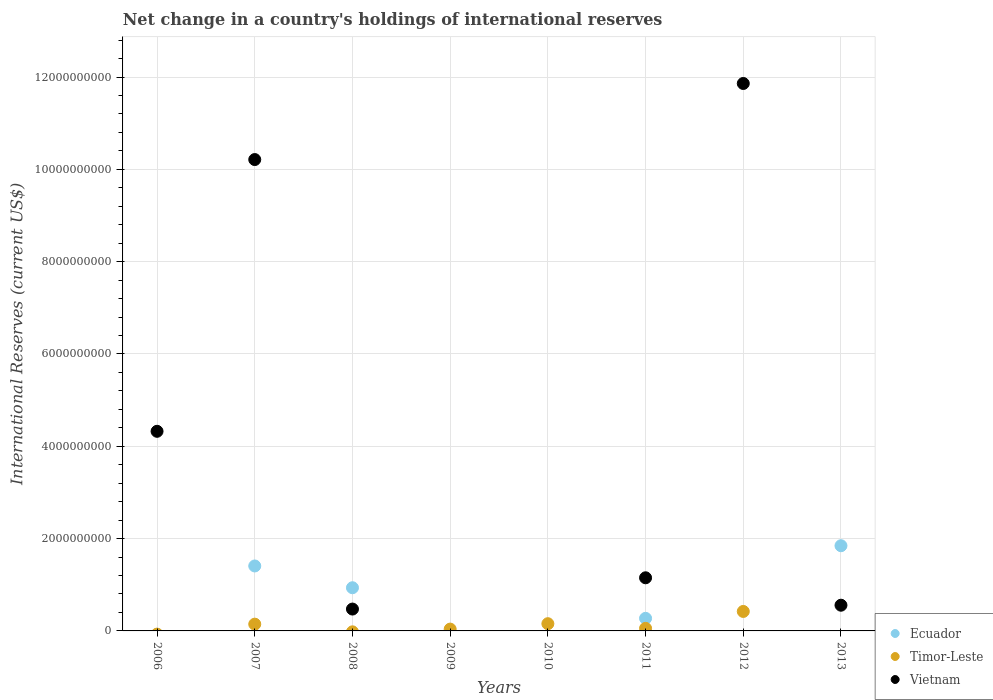What is the international reserves in Vietnam in 2008?
Give a very brief answer. 4.74e+08. Across all years, what is the maximum international reserves in Ecuador?
Provide a succinct answer. 1.85e+09. Across all years, what is the minimum international reserves in Ecuador?
Keep it short and to the point. 0. In which year was the international reserves in Timor-Leste maximum?
Give a very brief answer. 2012. What is the total international reserves in Timor-Leste in the graph?
Offer a terse response. 8.20e+08. What is the difference between the international reserves in Vietnam in 2008 and that in 2013?
Give a very brief answer. -8.34e+07. What is the difference between the international reserves in Vietnam in 2013 and the international reserves in Timor-Leste in 2007?
Make the answer very short. 4.10e+08. What is the average international reserves in Ecuador per year?
Your answer should be compact. 5.58e+08. In the year 2007, what is the difference between the international reserves in Timor-Leste and international reserves in Ecuador?
Your response must be concise. -1.26e+09. What is the ratio of the international reserves in Vietnam in 2006 to that in 2011?
Give a very brief answer. 3.76. Is the international reserves in Vietnam in 2006 less than that in 2012?
Your response must be concise. Yes. What is the difference between the highest and the second highest international reserves in Timor-Leste?
Keep it short and to the point. 2.65e+08. What is the difference between the highest and the lowest international reserves in Ecuador?
Offer a terse response. 1.85e+09. In how many years, is the international reserves in Timor-Leste greater than the average international reserves in Timor-Leste taken over all years?
Keep it short and to the point. 3. Is the international reserves in Ecuador strictly greater than the international reserves in Vietnam over the years?
Provide a succinct answer. No. Is the international reserves in Timor-Leste strictly less than the international reserves in Ecuador over the years?
Ensure brevity in your answer.  No. How many dotlines are there?
Offer a very short reply. 3. How many legend labels are there?
Offer a terse response. 3. How are the legend labels stacked?
Your answer should be very brief. Vertical. What is the title of the graph?
Offer a terse response. Net change in a country's holdings of international reserves. Does "Eritrea" appear as one of the legend labels in the graph?
Your answer should be compact. No. What is the label or title of the X-axis?
Offer a very short reply. Years. What is the label or title of the Y-axis?
Your response must be concise. International Reserves (current US$). What is the International Reserves (current US$) in Ecuador in 2006?
Give a very brief answer. 0. What is the International Reserves (current US$) of Timor-Leste in 2006?
Give a very brief answer. 0. What is the International Reserves (current US$) of Vietnam in 2006?
Provide a short and direct response. 4.32e+09. What is the International Reserves (current US$) of Ecuador in 2007?
Offer a very short reply. 1.41e+09. What is the International Reserves (current US$) in Timor-Leste in 2007?
Offer a very short reply. 1.47e+08. What is the International Reserves (current US$) of Vietnam in 2007?
Keep it short and to the point. 1.02e+1. What is the International Reserves (current US$) in Ecuador in 2008?
Give a very brief answer. 9.35e+08. What is the International Reserves (current US$) of Timor-Leste in 2008?
Provide a succinct answer. 0. What is the International Reserves (current US$) in Vietnam in 2008?
Offer a terse response. 4.74e+08. What is the International Reserves (current US$) of Ecuador in 2009?
Provide a succinct answer. 0. What is the International Reserves (current US$) of Timor-Leste in 2009?
Give a very brief answer. 3.95e+07. What is the International Reserves (current US$) of Vietnam in 2009?
Offer a terse response. 0. What is the International Reserves (current US$) of Timor-Leste in 2010?
Ensure brevity in your answer.  1.56e+08. What is the International Reserves (current US$) of Ecuador in 2011?
Your response must be concise. 2.72e+08. What is the International Reserves (current US$) of Timor-Leste in 2011?
Provide a succinct answer. 5.55e+07. What is the International Reserves (current US$) of Vietnam in 2011?
Your answer should be very brief. 1.15e+09. What is the International Reserves (current US$) in Timor-Leste in 2012?
Give a very brief answer. 4.22e+08. What is the International Reserves (current US$) of Vietnam in 2012?
Keep it short and to the point. 1.19e+1. What is the International Reserves (current US$) of Ecuador in 2013?
Ensure brevity in your answer.  1.85e+09. What is the International Reserves (current US$) of Vietnam in 2013?
Ensure brevity in your answer.  5.57e+08. Across all years, what is the maximum International Reserves (current US$) in Ecuador?
Ensure brevity in your answer.  1.85e+09. Across all years, what is the maximum International Reserves (current US$) in Timor-Leste?
Your answer should be compact. 4.22e+08. Across all years, what is the maximum International Reserves (current US$) in Vietnam?
Provide a succinct answer. 1.19e+1. Across all years, what is the minimum International Reserves (current US$) in Timor-Leste?
Keep it short and to the point. 0. What is the total International Reserves (current US$) in Ecuador in the graph?
Give a very brief answer. 4.46e+09. What is the total International Reserves (current US$) in Timor-Leste in the graph?
Your answer should be compact. 8.20e+08. What is the total International Reserves (current US$) in Vietnam in the graph?
Provide a succinct answer. 2.86e+1. What is the difference between the International Reserves (current US$) in Vietnam in 2006 and that in 2007?
Make the answer very short. -5.89e+09. What is the difference between the International Reserves (current US$) of Vietnam in 2006 and that in 2008?
Your response must be concise. 3.85e+09. What is the difference between the International Reserves (current US$) in Vietnam in 2006 and that in 2011?
Your response must be concise. 3.17e+09. What is the difference between the International Reserves (current US$) in Vietnam in 2006 and that in 2012?
Your answer should be very brief. -7.54e+09. What is the difference between the International Reserves (current US$) of Vietnam in 2006 and that in 2013?
Provide a short and direct response. 3.77e+09. What is the difference between the International Reserves (current US$) of Ecuador in 2007 and that in 2008?
Provide a short and direct response. 4.72e+08. What is the difference between the International Reserves (current US$) in Vietnam in 2007 and that in 2008?
Offer a very short reply. 9.74e+09. What is the difference between the International Reserves (current US$) of Timor-Leste in 2007 and that in 2009?
Your response must be concise. 1.07e+08. What is the difference between the International Reserves (current US$) of Timor-Leste in 2007 and that in 2010?
Keep it short and to the point. -9.96e+06. What is the difference between the International Reserves (current US$) in Ecuador in 2007 and that in 2011?
Your answer should be compact. 1.13e+09. What is the difference between the International Reserves (current US$) of Timor-Leste in 2007 and that in 2011?
Give a very brief answer. 9.11e+07. What is the difference between the International Reserves (current US$) in Vietnam in 2007 and that in 2011?
Keep it short and to the point. 9.06e+09. What is the difference between the International Reserves (current US$) in Timor-Leste in 2007 and that in 2012?
Offer a terse response. -2.75e+08. What is the difference between the International Reserves (current US$) of Vietnam in 2007 and that in 2012?
Your answer should be compact. -1.65e+09. What is the difference between the International Reserves (current US$) of Ecuador in 2007 and that in 2013?
Your answer should be very brief. -4.39e+08. What is the difference between the International Reserves (current US$) of Vietnam in 2007 and that in 2013?
Give a very brief answer. 9.65e+09. What is the difference between the International Reserves (current US$) of Ecuador in 2008 and that in 2011?
Provide a short and direct response. 6.63e+08. What is the difference between the International Reserves (current US$) of Vietnam in 2008 and that in 2011?
Provide a succinct answer. -6.77e+08. What is the difference between the International Reserves (current US$) of Vietnam in 2008 and that in 2012?
Provide a short and direct response. -1.14e+1. What is the difference between the International Reserves (current US$) of Ecuador in 2008 and that in 2013?
Offer a terse response. -9.10e+08. What is the difference between the International Reserves (current US$) in Vietnam in 2008 and that in 2013?
Give a very brief answer. -8.34e+07. What is the difference between the International Reserves (current US$) in Timor-Leste in 2009 and that in 2010?
Make the answer very short. -1.17e+08. What is the difference between the International Reserves (current US$) in Timor-Leste in 2009 and that in 2011?
Your answer should be compact. -1.60e+07. What is the difference between the International Reserves (current US$) of Timor-Leste in 2009 and that in 2012?
Ensure brevity in your answer.  -3.82e+08. What is the difference between the International Reserves (current US$) of Timor-Leste in 2010 and that in 2011?
Offer a very short reply. 1.01e+08. What is the difference between the International Reserves (current US$) of Timor-Leste in 2010 and that in 2012?
Offer a terse response. -2.65e+08. What is the difference between the International Reserves (current US$) in Timor-Leste in 2011 and that in 2012?
Ensure brevity in your answer.  -3.66e+08. What is the difference between the International Reserves (current US$) in Vietnam in 2011 and that in 2012?
Make the answer very short. -1.07e+1. What is the difference between the International Reserves (current US$) of Ecuador in 2011 and that in 2013?
Provide a succinct answer. -1.57e+09. What is the difference between the International Reserves (current US$) of Vietnam in 2011 and that in 2013?
Give a very brief answer. 5.94e+08. What is the difference between the International Reserves (current US$) in Vietnam in 2012 and that in 2013?
Ensure brevity in your answer.  1.13e+1. What is the difference between the International Reserves (current US$) in Ecuador in 2007 and the International Reserves (current US$) in Vietnam in 2008?
Offer a terse response. 9.34e+08. What is the difference between the International Reserves (current US$) in Timor-Leste in 2007 and the International Reserves (current US$) in Vietnam in 2008?
Keep it short and to the point. -3.27e+08. What is the difference between the International Reserves (current US$) of Ecuador in 2007 and the International Reserves (current US$) of Timor-Leste in 2009?
Offer a terse response. 1.37e+09. What is the difference between the International Reserves (current US$) of Ecuador in 2007 and the International Reserves (current US$) of Timor-Leste in 2010?
Give a very brief answer. 1.25e+09. What is the difference between the International Reserves (current US$) of Ecuador in 2007 and the International Reserves (current US$) of Timor-Leste in 2011?
Make the answer very short. 1.35e+09. What is the difference between the International Reserves (current US$) of Ecuador in 2007 and the International Reserves (current US$) of Vietnam in 2011?
Offer a terse response. 2.56e+08. What is the difference between the International Reserves (current US$) in Timor-Leste in 2007 and the International Reserves (current US$) in Vietnam in 2011?
Ensure brevity in your answer.  -1.00e+09. What is the difference between the International Reserves (current US$) of Ecuador in 2007 and the International Reserves (current US$) of Timor-Leste in 2012?
Offer a very short reply. 9.85e+08. What is the difference between the International Reserves (current US$) of Ecuador in 2007 and the International Reserves (current US$) of Vietnam in 2012?
Keep it short and to the point. -1.05e+1. What is the difference between the International Reserves (current US$) of Timor-Leste in 2007 and the International Reserves (current US$) of Vietnam in 2012?
Make the answer very short. -1.17e+1. What is the difference between the International Reserves (current US$) of Ecuador in 2007 and the International Reserves (current US$) of Vietnam in 2013?
Your answer should be compact. 8.50e+08. What is the difference between the International Reserves (current US$) in Timor-Leste in 2007 and the International Reserves (current US$) in Vietnam in 2013?
Offer a very short reply. -4.10e+08. What is the difference between the International Reserves (current US$) of Ecuador in 2008 and the International Reserves (current US$) of Timor-Leste in 2009?
Keep it short and to the point. 8.96e+08. What is the difference between the International Reserves (current US$) in Ecuador in 2008 and the International Reserves (current US$) in Timor-Leste in 2010?
Provide a succinct answer. 7.79e+08. What is the difference between the International Reserves (current US$) of Ecuador in 2008 and the International Reserves (current US$) of Timor-Leste in 2011?
Give a very brief answer. 8.80e+08. What is the difference between the International Reserves (current US$) of Ecuador in 2008 and the International Reserves (current US$) of Vietnam in 2011?
Your answer should be compact. -2.16e+08. What is the difference between the International Reserves (current US$) of Ecuador in 2008 and the International Reserves (current US$) of Timor-Leste in 2012?
Keep it short and to the point. 5.14e+08. What is the difference between the International Reserves (current US$) of Ecuador in 2008 and the International Reserves (current US$) of Vietnam in 2012?
Keep it short and to the point. -1.09e+1. What is the difference between the International Reserves (current US$) of Ecuador in 2008 and the International Reserves (current US$) of Vietnam in 2013?
Your answer should be very brief. 3.79e+08. What is the difference between the International Reserves (current US$) in Timor-Leste in 2009 and the International Reserves (current US$) in Vietnam in 2011?
Offer a very short reply. -1.11e+09. What is the difference between the International Reserves (current US$) of Timor-Leste in 2009 and the International Reserves (current US$) of Vietnam in 2012?
Ensure brevity in your answer.  -1.18e+1. What is the difference between the International Reserves (current US$) in Timor-Leste in 2009 and the International Reserves (current US$) in Vietnam in 2013?
Offer a terse response. -5.17e+08. What is the difference between the International Reserves (current US$) of Timor-Leste in 2010 and the International Reserves (current US$) of Vietnam in 2011?
Your answer should be very brief. -9.95e+08. What is the difference between the International Reserves (current US$) in Timor-Leste in 2010 and the International Reserves (current US$) in Vietnam in 2012?
Your answer should be very brief. -1.17e+1. What is the difference between the International Reserves (current US$) in Timor-Leste in 2010 and the International Reserves (current US$) in Vietnam in 2013?
Give a very brief answer. -4.00e+08. What is the difference between the International Reserves (current US$) in Ecuador in 2011 and the International Reserves (current US$) in Timor-Leste in 2012?
Provide a succinct answer. -1.49e+08. What is the difference between the International Reserves (current US$) in Ecuador in 2011 and the International Reserves (current US$) in Vietnam in 2012?
Make the answer very short. -1.16e+1. What is the difference between the International Reserves (current US$) of Timor-Leste in 2011 and the International Reserves (current US$) of Vietnam in 2012?
Keep it short and to the point. -1.18e+1. What is the difference between the International Reserves (current US$) of Ecuador in 2011 and the International Reserves (current US$) of Vietnam in 2013?
Give a very brief answer. -2.84e+08. What is the difference between the International Reserves (current US$) of Timor-Leste in 2011 and the International Reserves (current US$) of Vietnam in 2013?
Offer a terse response. -5.01e+08. What is the difference between the International Reserves (current US$) in Timor-Leste in 2012 and the International Reserves (current US$) in Vietnam in 2013?
Your answer should be compact. -1.35e+08. What is the average International Reserves (current US$) in Ecuador per year?
Offer a very short reply. 5.58e+08. What is the average International Reserves (current US$) in Timor-Leste per year?
Your response must be concise. 1.02e+08. What is the average International Reserves (current US$) of Vietnam per year?
Your answer should be very brief. 3.57e+09. In the year 2007, what is the difference between the International Reserves (current US$) in Ecuador and International Reserves (current US$) in Timor-Leste?
Offer a terse response. 1.26e+09. In the year 2007, what is the difference between the International Reserves (current US$) of Ecuador and International Reserves (current US$) of Vietnam?
Offer a terse response. -8.80e+09. In the year 2007, what is the difference between the International Reserves (current US$) of Timor-Leste and International Reserves (current US$) of Vietnam?
Your answer should be very brief. -1.01e+1. In the year 2008, what is the difference between the International Reserves (current US$) in Ecuador and International Reserves (current US$) in Vietnam?
Ensure brevity in your answer.  4.62e+08. In the year 2011, what is the difference between the International Reserves (current US$) of Ecuador and International Reserves (current US$) of Timor-Leste?
Your response must be concise. 2.17e+08. In the year 2011, what is the difference between the International Reserves (current US$) in Ecuador and International Reserves (current US$) in Vietnam?
Provide a succinct answer. -8.79e+08. In the year 2011, what is the difference between the International Reserves (current US$) of Timor-Leste and International Reserves (current US$) of Vietnam?
Provide a succinct answer. -1.10e+09. In the year 2012, what is the difference between the International Reserves (current US$) in Timor-Leste and International Reserves (current US$) in Vietnam?
Your response must be concise. -1.14e+1. In the year 2013, what is the difference between the International Reserves (current US$) in Ecuador and International Reserves (current US$) in Vietnam?
Give a very brief answer. 1.29e+09. What is the ratio of the International Reserves (current US$) of Vietnam in 2006 to that in 2007?
Provide a short and direct response. 0.42. What is the ratio of the International Reserves (current US$) of Vietnam in 2006 to that in 2008?
Make the answer very short. 9.13. What is the ratio of the International Reserves (current US$) in Vietnam in 2006 to that in 2011?
Ensure brevity in your answer.  3.76. What is the ratio of the International Reserves (current US$) of Vietnam in 2006 to that in 2012?
Ensure brevity in your answer.  0.36. What is the ratio of the International Reserves (current US$) in Vietnam in 2006 to that in 2013?
Make the answer very short. 7.76. What is the ratio of the International Reserves (current US$) of Ecuador in 2007 to that in 2008?
Give a very brief answer. 1.5. What is the ratio of the International Reserves (current US$) of Vietnam in 2007 to that in 2008?
Your answer should be compact. 21.56. What is the ratio of the International Reserves (current US$) in Timor-Leste in 2007 to that in 2009?
Your answer should be compact. 3.71. What is the ratio of the International Reserves (current US$) in Timor-Leste in 2007 to that in 2010?
Provide a short and direct response. 0.94. What is the ratio of the International Reserves (current US$) in Ecuador in 2007 to that in 2011?
Offer a terse response. 5.16. What is the ratio of the International Reserves (current US$) of Timor-Leste in 2007 to that in 2011?
Your response must be concise. 2.64. What is the ratio of the International Reserves (current US$) of Vietnam in 2007 to that in 2011?
Offer a terse response. 8.87. What is the ratio of the International Reserves (current US$) of Timor-Leste in 2007 to that in 2012?
Keep it short and to the point. 0.35. What is the ratio of the International Reserves (current US$) of Vietnam in 2007 to that in 2012?
Make the answer very short. 0.86. What is the ratio of the International Reserves (current US$) of Ecuador in 2007 to that in 2013?
Your answer should be very brief. 0.76. What is the ratio of the International Reserves (current US$) of Vietnam in 2007 to that in 2013?
Keep it short and to the point. 18.34. What is the ratio of the International Reserves (current US$) in Ecuador in 2008 to that in 2011?
Give a very brief answer. 3.43. What is the ratio of the International Reserves (current US$) of Vietnam in 2008 to that in 2011?
Give a very brief answer. 0.41. What is the ratio of the International Reserves (current US$) of Vietnam in 2008 to that in 2012?
Your response must be concise. 0.04. What is the ratio of the International Reserves (current US$) in Ecuador in 2008 to that in 2013?
Ensure brevity in your answer.  0.51. What is the ratio of the International Reserves (current US$) in Vietnam in 2008 to that in 2013?
Your answer should be compact. 0.85. What is the ratio of the International Reserves (current US$) in Timor-Leste in 2009 to that in 2010?
Your answer should be very brief. 0.25. What is the ratio of the International Reserves (current US$) in Timor-Leste in 2009 to that in 2011?
Keep it short and to the point. 0.71. What is the ratio of the International Reserves (current US$) in Timor-Leste in 2009 to that in 2012?
Offer a terse response. 0.09. What is the ratio of the International Reserves (current US$) of Timor-Leste in 2010 to that in 2011?
Provide a short and direct response. 2.82. What is the ratio of the International Reserves (current US$) of Timor-Leste in 2010 to that in 2012?
Your answer should be very brief. 0.37. What is the ratio of the International Reserves (current US$) of Timor-Leste in 2011 to that in 2012?
Offer a very short reply. 0.13. What is the ratio of the International Reserves (current US$) of Vietnam in 2011 to that in 2012?
Your answer should be compact. 0.1. What is the ratio of the International Reserves (current US$) of Ecuador in 2011 to that in 2013?
Provide a short and direct response. 0.15. What is the ratio of the International Reserves (current US$) of Vietnam in 2011 to that in 2013?
Your response must be concise. 2.07. What is the ratio of the International Reserves (current US$) in Vietnam in 2012 to that in 2013?
Keep it short and to the point. 21.29. What is the difference between the highest and the second highest International Reserves (current US$) in Ecuador?
Ensure brevity in your answer.  4.39e+08. What is the difference between the highest and the second highest International Reserves (current US$) of Timor-Leste?
Ensure brevity in your answer.  2.65e+08. What is the difference between the highest and the second highest International Reserves (current US$) of Vietnam?
Keep it short and to the point. 1.65e+09. What is the difference between the highest and the lowest International Reserves (current US$) of Ecuador?
Offer a very short reply. 1.85e+09. What is the difference between the highest and the lowest International Reserves (current US$) of Timor-Leste?
Your answer should be very brief. 4.22e+08. What is the difference between the highest and the lowest International Reserves (current US$) of Vietnam?
Your response must be concise. 1.19e+1. 